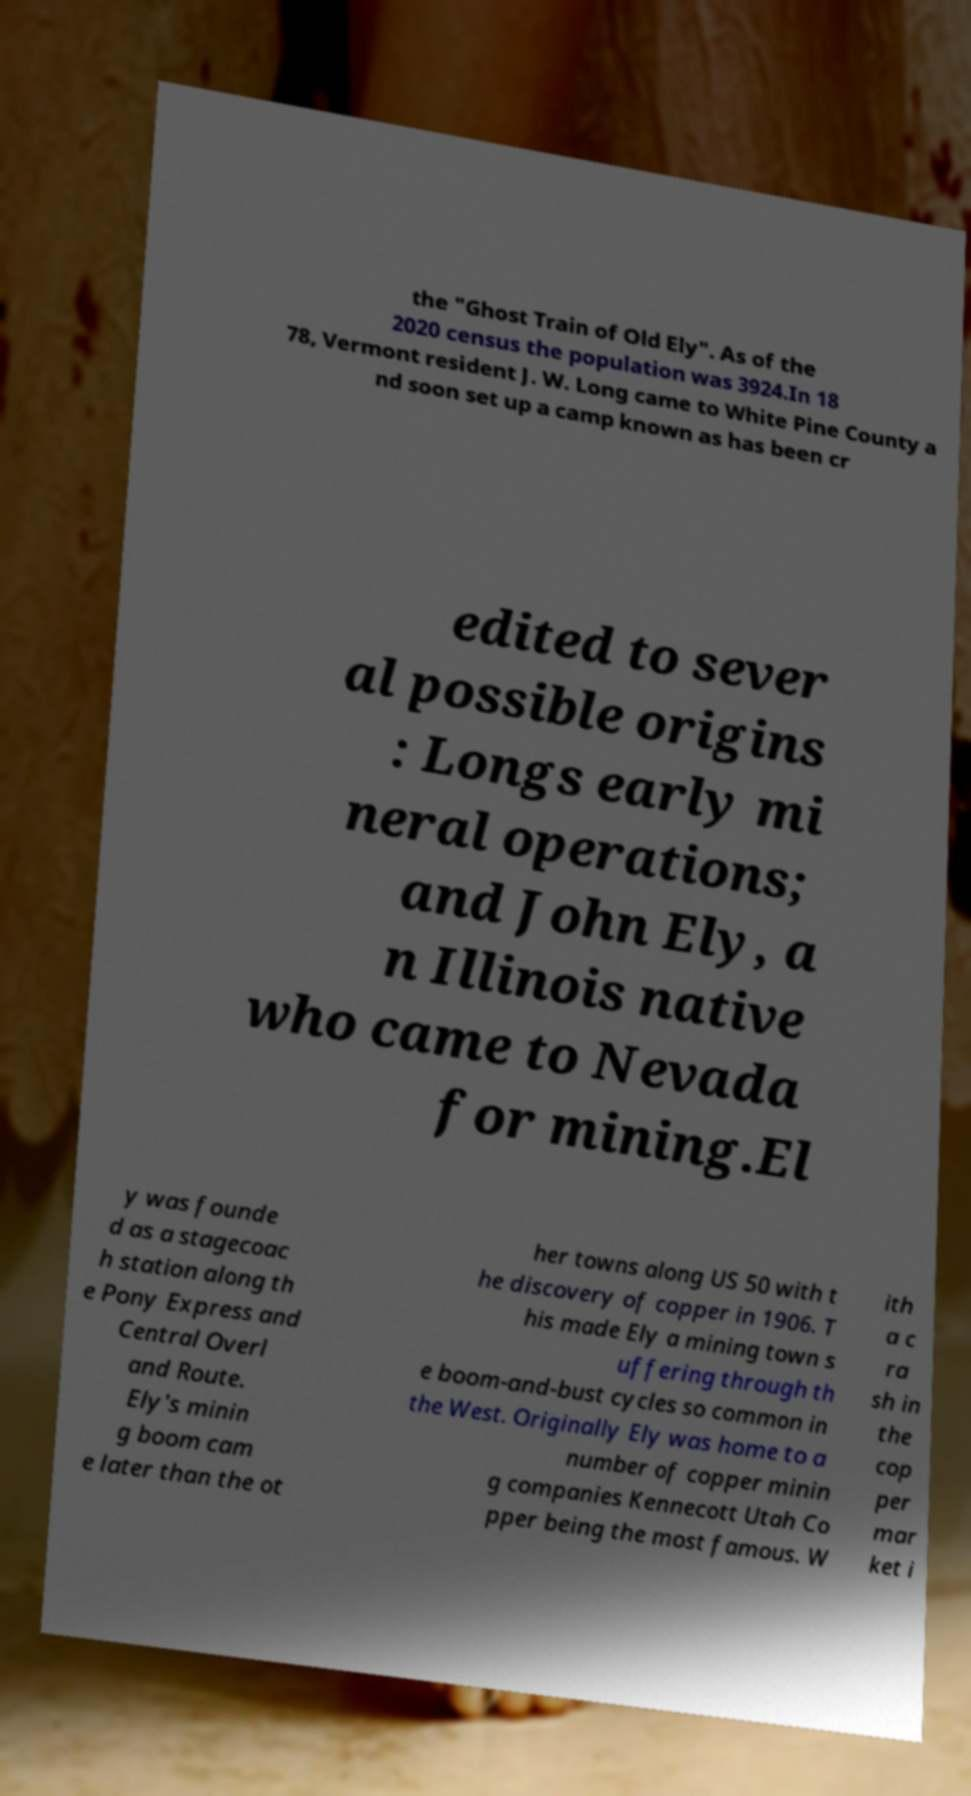What messages or text are displayed in this image? I need them in a readable, typed format. the "Ghost Train of Old Ely". As of the 2020 census the population was 3924.In 18 78, Vermont resident J. W. Long came to White Pine County a nd soon set up a camp known as has been cr edited to sever al possible origins : Longs early mi neral operations; and John Ely, a n Illinois native who came to Nevada for mining.El y was founde d as a stagecoac h station along th e Pony Express and Central Overl and Route. Ely's minin g boom cam e later than the ot her towns along US 50 with t he discovery of copper in 1906. T his made Ely a mining town s uffering through th e boom-and-bust cycles so common in the West. Originally Ely was home to a number of copper minin g companies Kennecott Utah Co pper being the most famous. W ith a c ra sh in the cop per mar ket i 